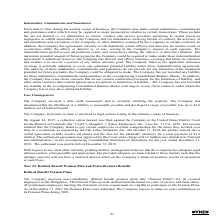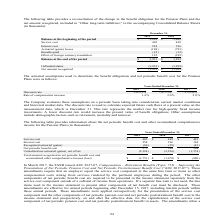According to Sykes Enterprises Incorporated's financial document, What was the service cost in 2019? According to the financial document, 405 (in thousands). The relevant text states: "Service cost 405 448..." Also, What was the  Interest cost  in 2018? According to the financial document, 196 (in thousands). The relevant text states: "Interest cost 254 196..." Also, In which years is the reconciliation of the change in the benefit obligation for the Pension Plans and the net amount recognized calculated? The document shows two values: 2019 and 2018. From the document: "2019 2018 2019 2018..." Additionally, In which year was service cost larger? According to the financial document, 2018. The relevant text states: "2019 2018..." Also, can you calculate: What was the change in interest cost in 2019 from 2018? Based on the calculation: 254-196, the result is 58 (in thousands). This is based on the information: "Interest cost 254 196 Interest cost 254 196..." The key data points involved are: 196, 254. Also, can you calculate: What was the percentage change in interest cost in 2019 from 2018? To answer this question, I need to perform calculations using the financial data. The calculation is: (254-196)/196, which equals 29.59 (percentage). This is based on the information: "Interest cost 254 196 Interest cost 254 196..." The key data points involved are: 196, 254. 